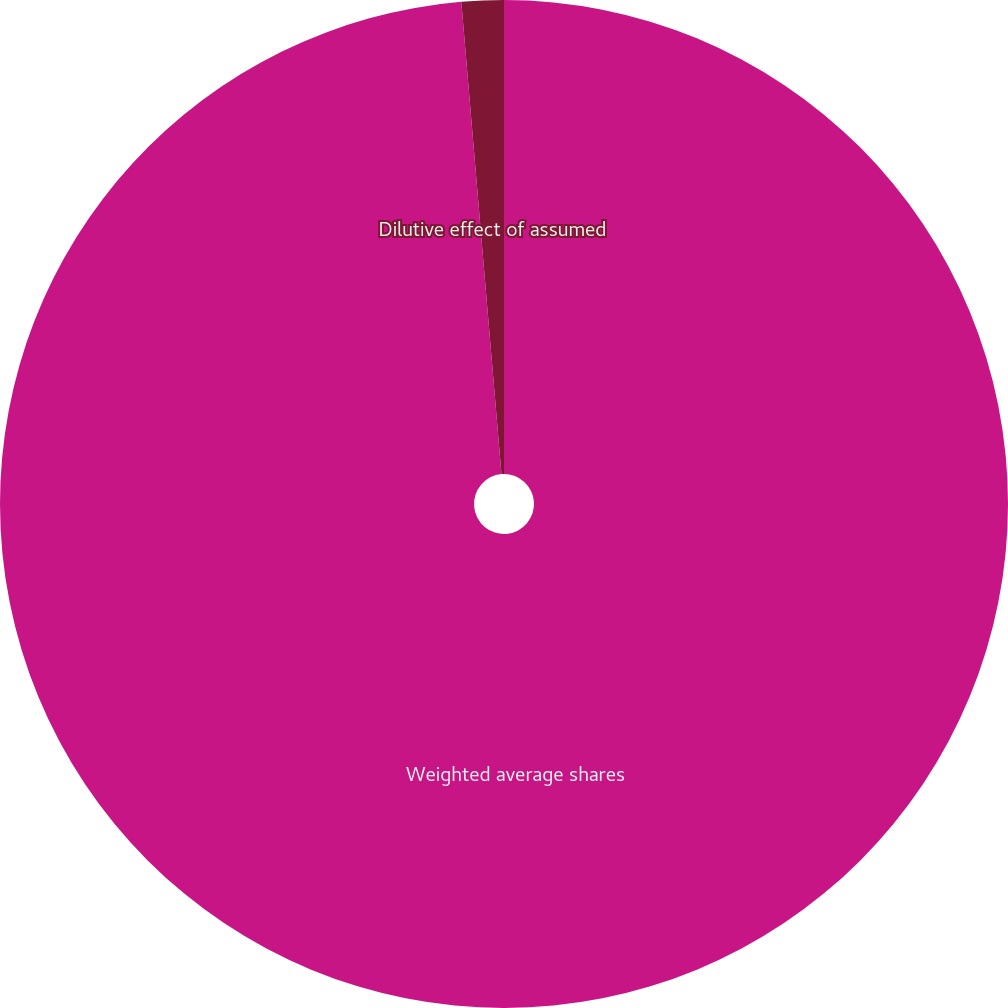Convert chart. <chart><loc_0><loc_0><loc_500><loc_500><pie_chart><fcel>Weighted average shares<fcel>Dilutive effect of assumed<nl><fcel>98.65%<fcel>1.35%<nl></chart> 